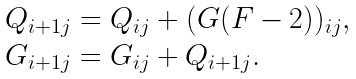Convert formula to latex. <formula><loc_0><loc_0><loc_500><loc_500>\begin{array} l Q _ { i + 1 j } = Q _ { i j } + ( G ( F - 2 ) ) _ { i j } , \\ G _ { i + 1 j } = G _ { i j } + Q _ { i + 1 j } . \end{array}</formula> 